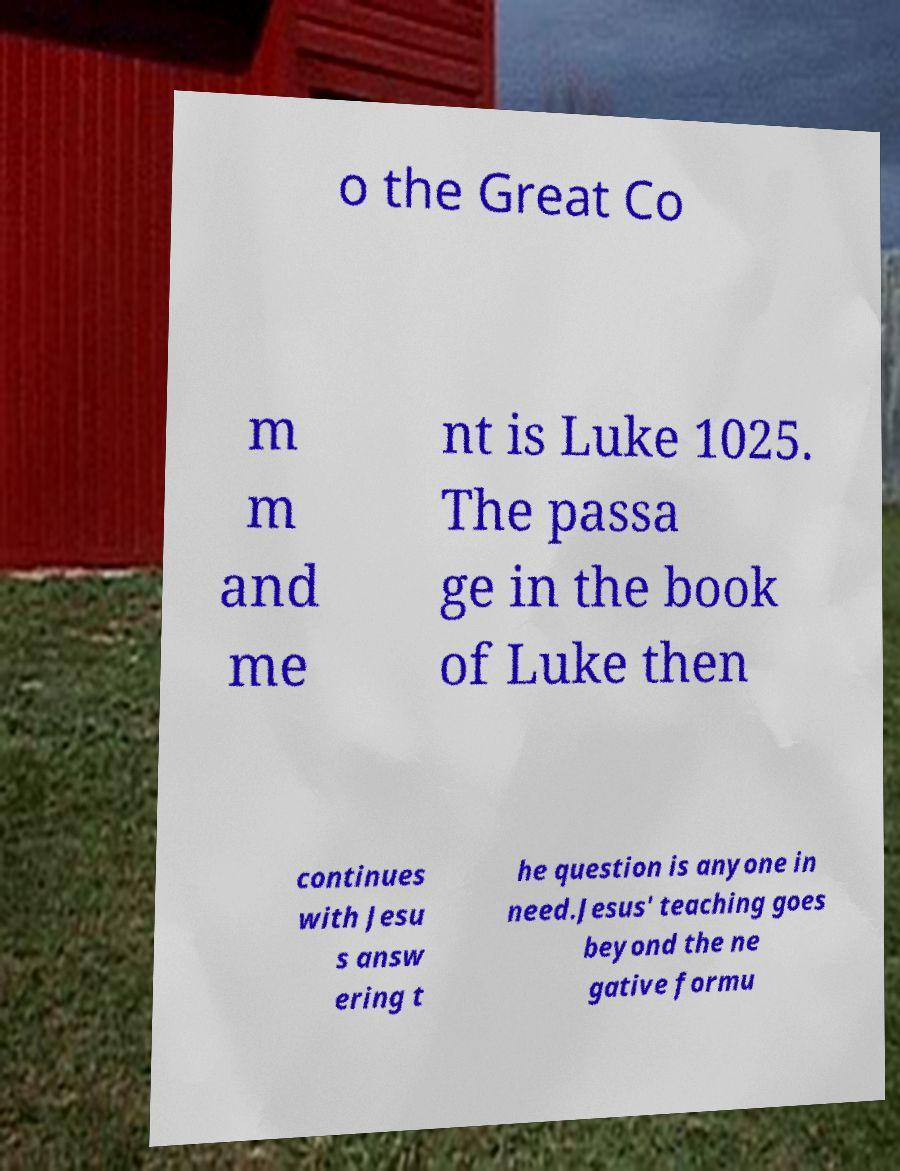Could you assist in decoding the text presented in this image and type it out clearly? o the Great Co m m and me nt is Luke 1025. The passa ge in the book of Luke then continues with Jesu s answ ering t he question is anyone in need.Jesus' teaching goes beyond the ne gative formu 